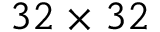<formula> <loc_0><loc_0><loc_500><loc_500>3 2 \times 3 2</formula> 